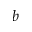Convert formula to latex. <formula><loc_0><loc_0><loc_500><loc_500>b</formula> 